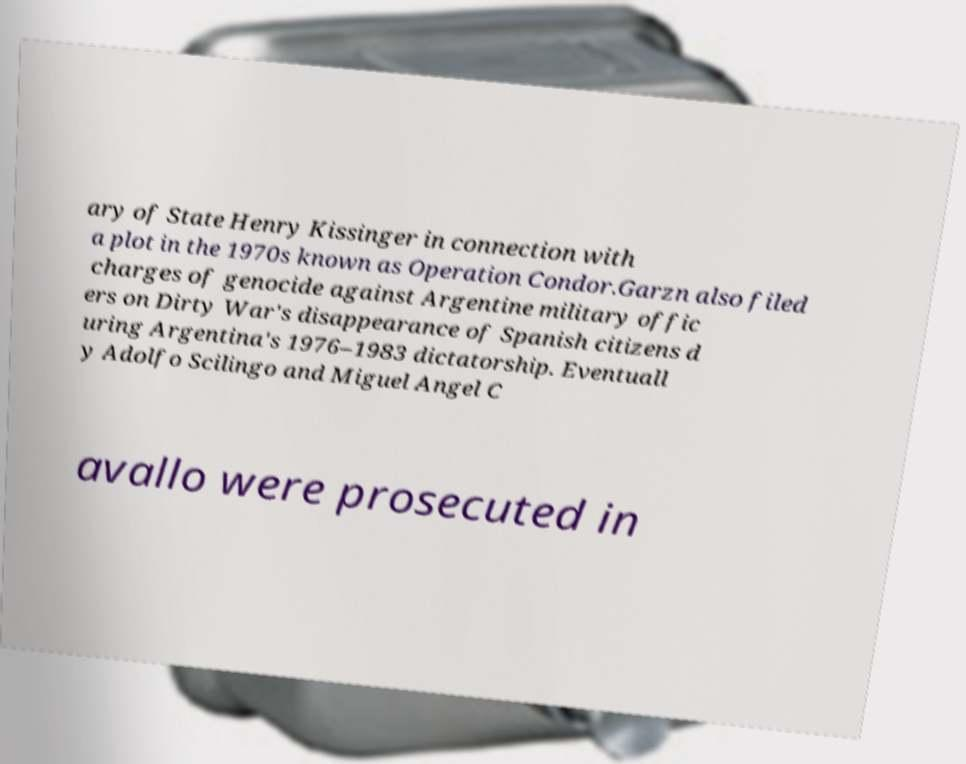For documentation purposes, I need the text within this image transcribed. Could you provide that? ary of State Henry Kissinger in connection with a plot in the 1970s known as Operation Condor.Garzn also filed charges of genocide against Argentine military offic ers on Dirty War's disappearance of Spanish citizens d uring Argentina's 1976–1983 dictatorship. Eventuall y Adolfo Scilingo and Miguel Angel C avallo were prosecuted in 